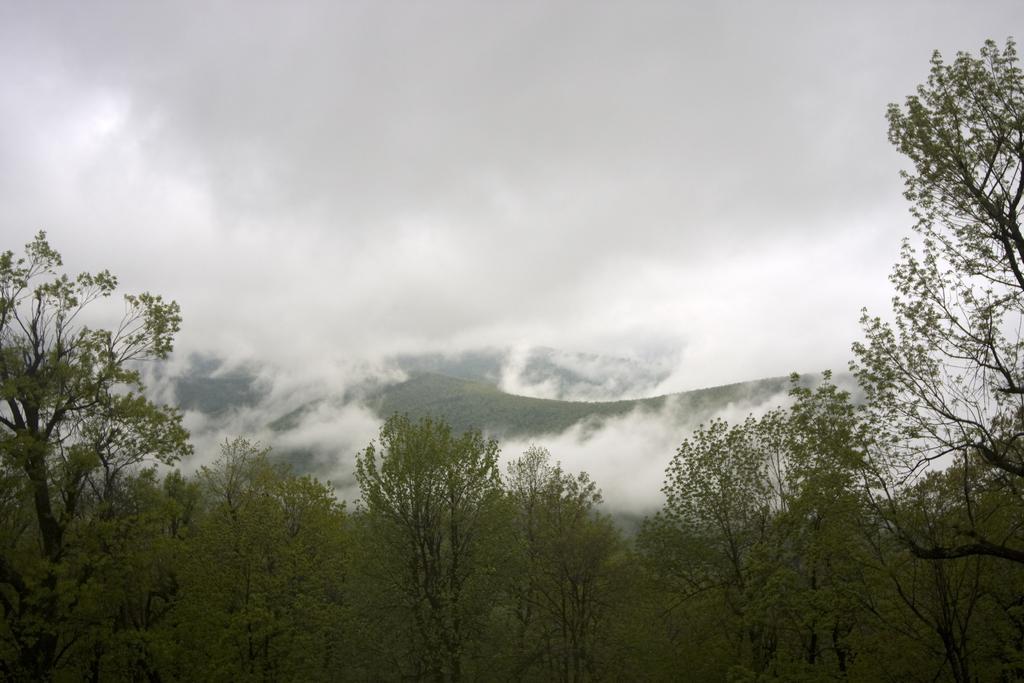How would you summarize this image in a sentence or two? In this image at the bottom, there are trees. In the middle there are hills, fog, sky. 